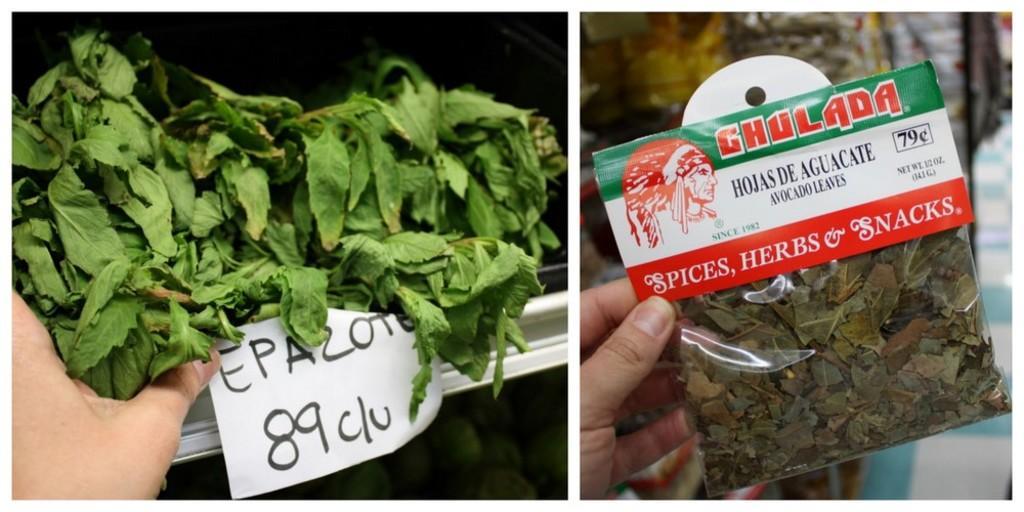Could you give a brief overview of what you see in this image? This image is a collage of two images. On the left side of the image there are a few green leaves. There is a paper with a text on it and there is a hand of a person. On the right side of the image of a person is holding a packet of spices in hand. There is a text on the packet. In the background there are a few things. 